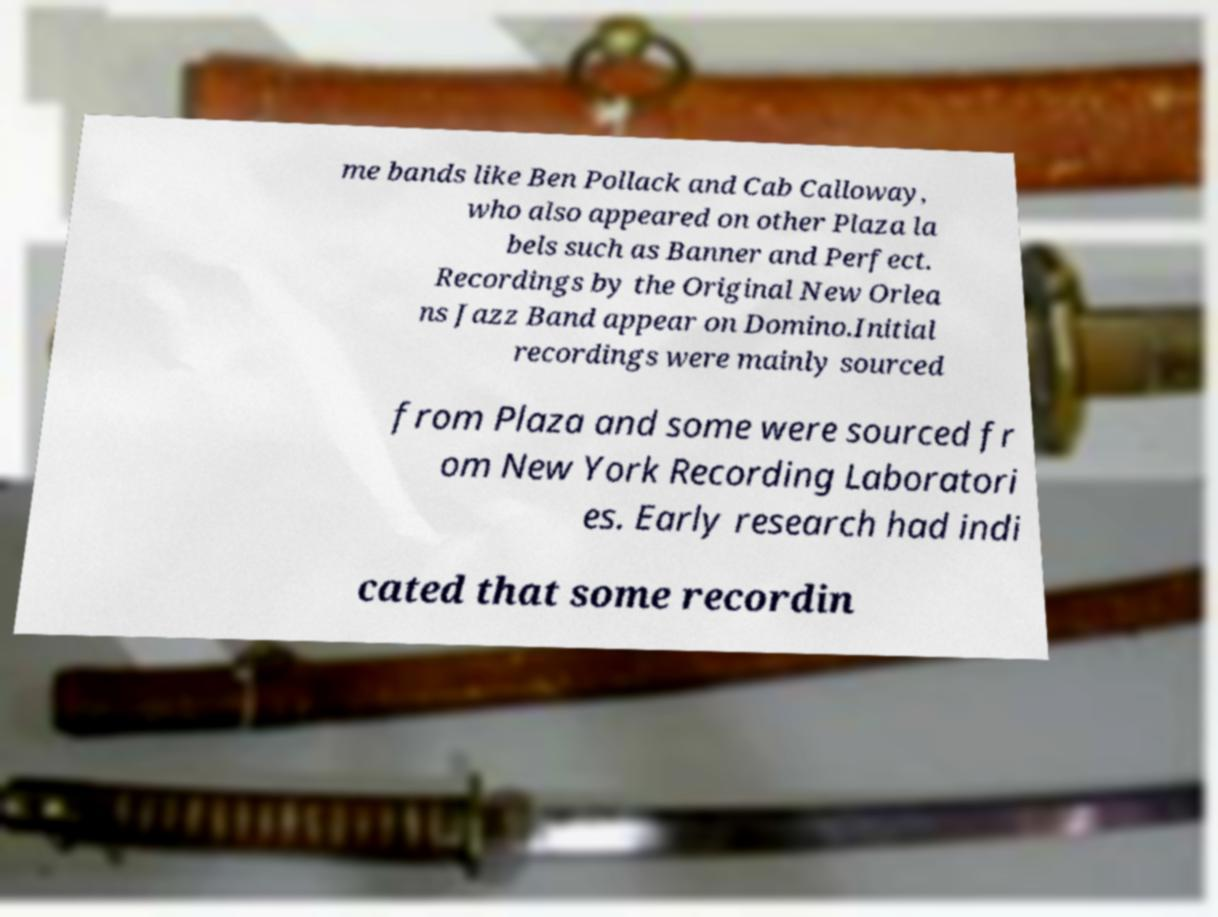Could you assist in decoding the text presented in this image and type it out clearly? me bands like Ben Pollack and Cab Calloway, who also appeared on other Plaza la bels such as Banner and Perfect. Recordings by the Original New Orlea ns Jazz Band appear on Domino.Initial recordings were mainly sourced from Plaza and some were sourced fr om New York Recording Laboratori es. Early research had indi cated that some recordin 